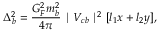Convert formula to latex. <formula><loc_0><loc_0><loc_500><loc_500>\Delta _ { b } ^ { 2 } = \frac { G _ { F } ^ { 2 } m _ { b } ^ { 2 } } { 4 \pi } | V _ { c b } | ^ { 2 } [ l _ { 1 } x + l _ { 2 } y ] \/ ,</formula> 